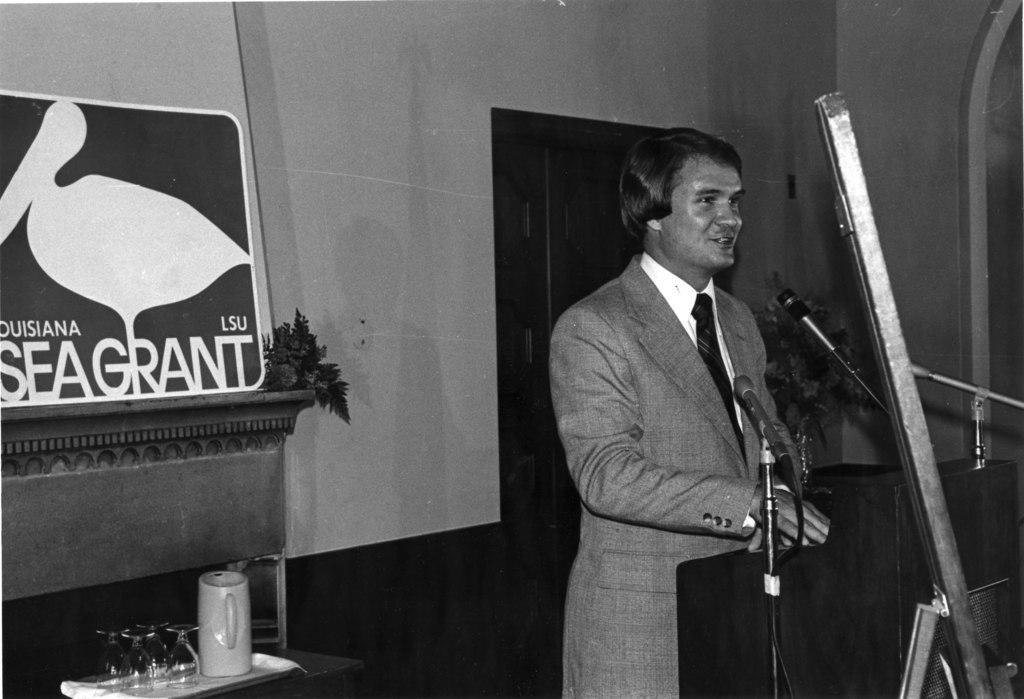In one or two sentences, can you explain what this image depicts? It is a black and white image, there is a person standing in front of a table and speaking something through the mic, on the left side there is another table and there is a flask and glasses kept on the table. In the background there is a wall and there is a poster in front of the wall, beside the poster there is a small plant. 